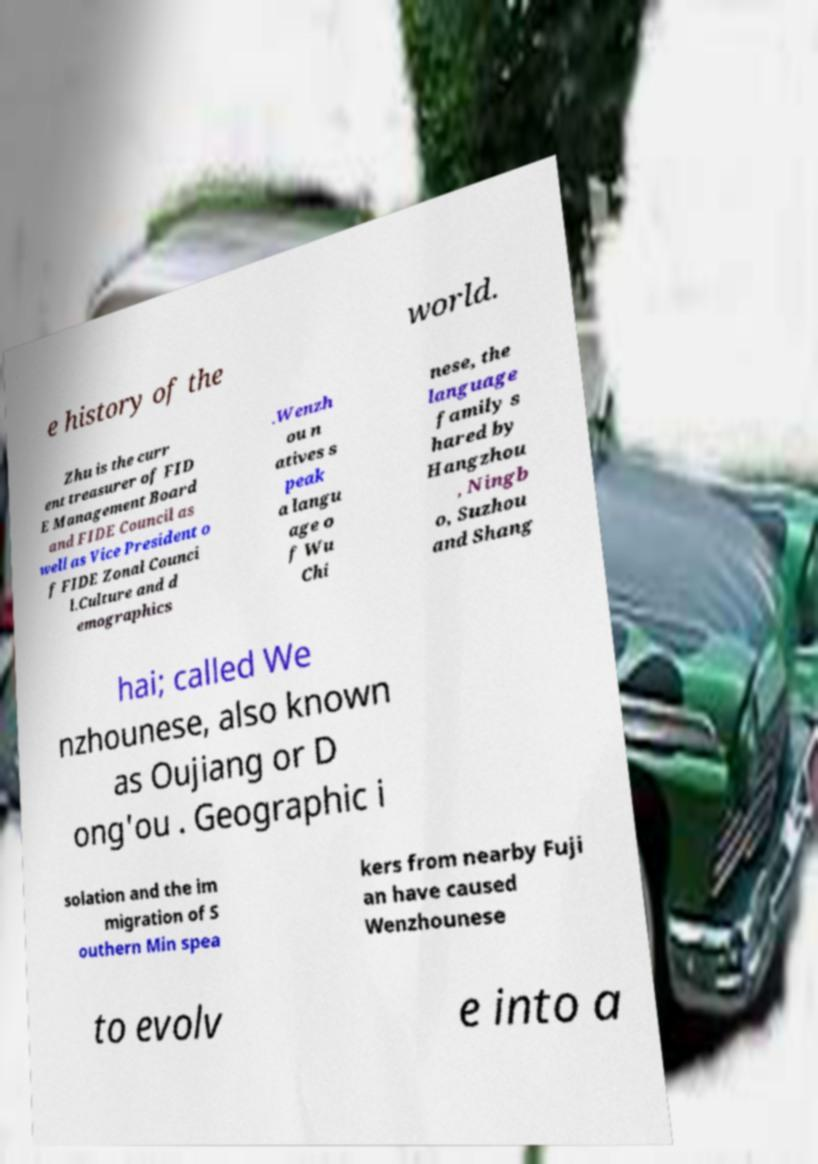Can you read and provide the text displayed in the image?This photo seems to have some interesting text. Can you extract and type it out for me? e history of the world. Zhu is the curr ent treasurer of FID E Management Board and FIDE Council as well as Vice President o f FIDE Zonal Counci l.Culture and d emographics .Wenzh ou n atives s peak a langu age o f Wu Chi nese, the language family s hared by Hangzhou , Ningb o, Suzhou and Shang hai; called We nzhounese, also known as Oujiang or D ong'ou . Geographic i solation and the im migration of S outhern Min spea kers from nearby Fuji an have caused Wenzhounese to evolv e into a 